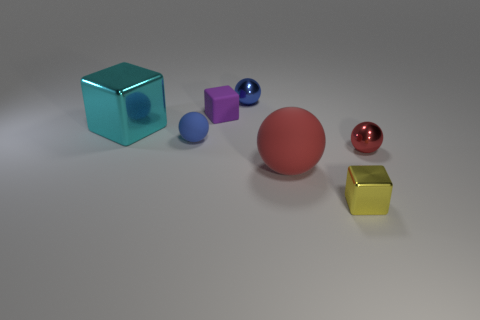Subtract all yellow spheres. Subtract all green cylinders. How many spheres are left? 4 Add 1 tiny purple objects. How many objects exist? 8 Subtract all blocks. How many objects are left? 4 Add 3 cyan cubes. How many cyan cubes exist? 4 Subtract 0 blue cubes. How many objects are left? 7 Subtract all red shiny objects. Subtract all small red metallic spheres. How many objects are left? 5 Add 3 blocks. How many blocks are left? 6 